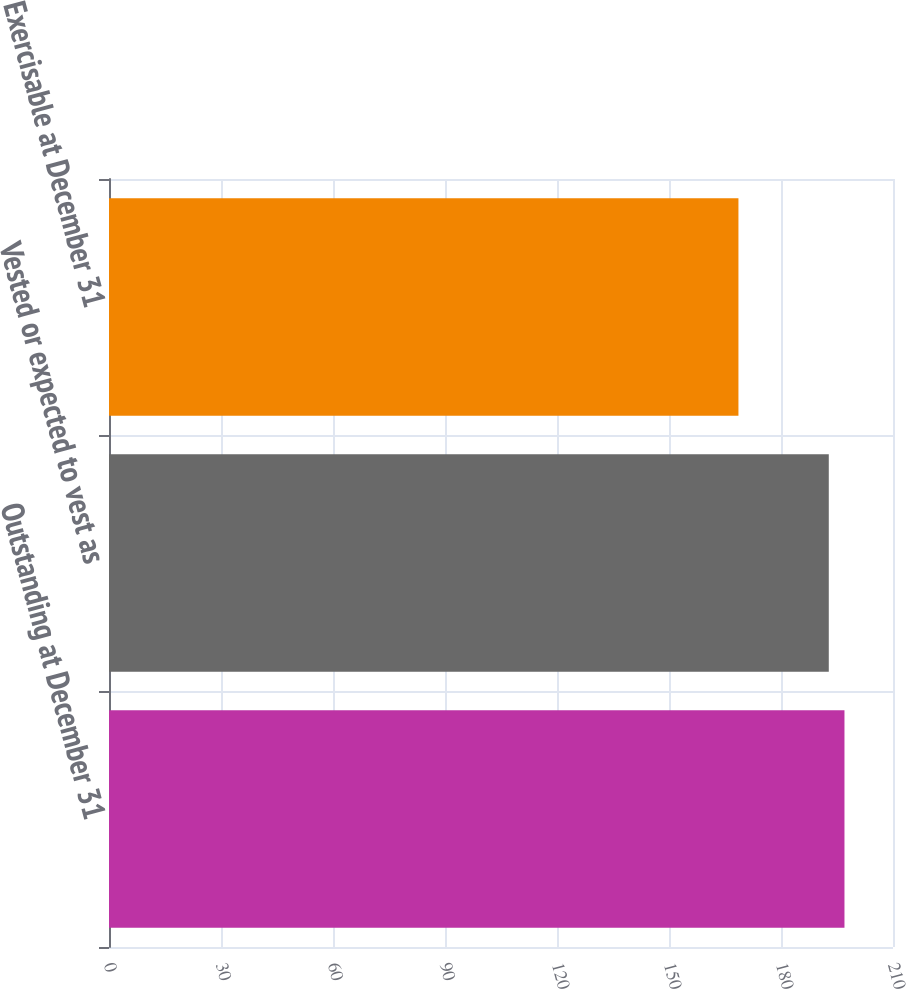Convert chart to OTSL. <chart><loc_0><loc_0><loc_500><loc_500><bar_chart><fcel>Outstanding at December 31<fcel>Vested or expected to vest as<fcel>Exercisable at December 31<nl><fcel>197<fcel>192.8<fcel>168.6<nl></chart> 